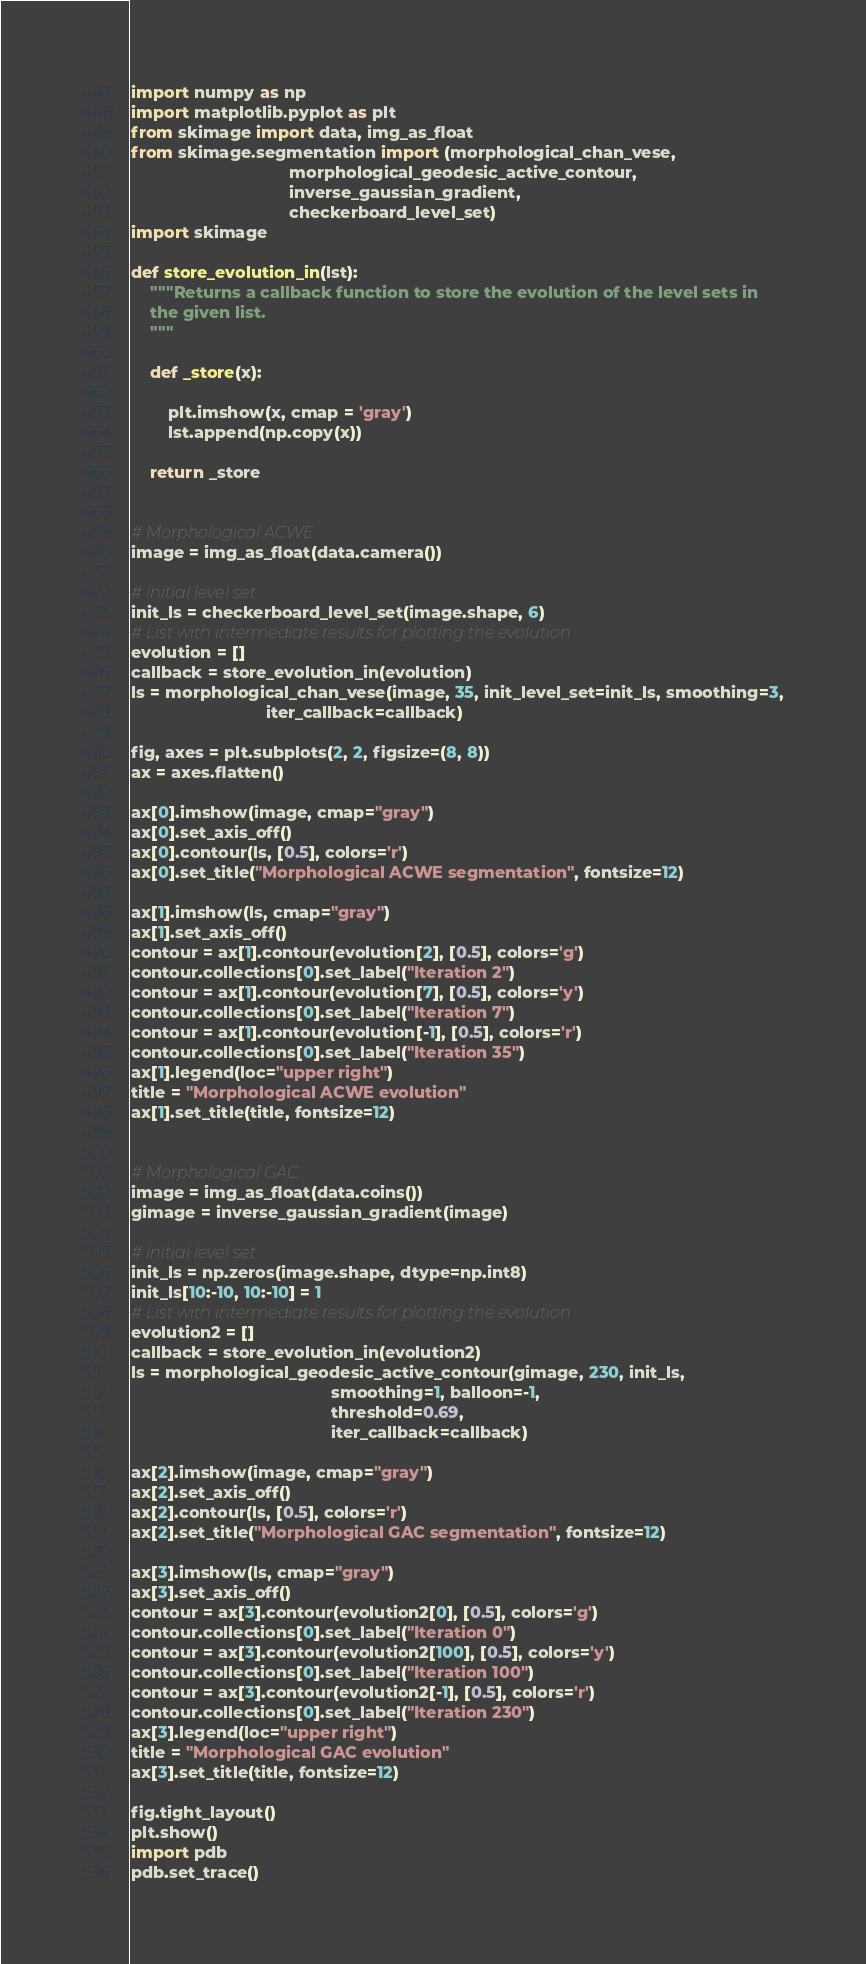<code> <loc_0><loc_0><loc_500><loc_500><_Python_>
import numpy as np
import matplotlib.pyplot as plt
from skimage import data, img_as_float
from skimage.segmentation import (morphological_chan_vese,
								  morphological_geodesic_active_contour,
								  inverse_gaussian_gradient,
								  checkerboard_level_set)
import skimage

def store_evolution_in(lst):
	"""Returns a callback function to store the evolution of the level sets in
	the given list.
	"""

	def _store(x):

		plt.imshow(x, cmap = 'gray')
		lst.append(np.copy(x))

	return _store


# Morphological ACWE
image = img_as_float(data.camera())

# Initial level set
init_ls = checkerboard_level_set(image.shape, 6)
# List with intermediate results for plotting the evolution
evolution = []
callback = store_evolution_in(evolution)
ls = morphological_chan_vese(image, 35, init_level_set=init_ls, smoothing=3,
							 iter_callback=callback)

fig, axes = plt.subplots(2, 2, figsize=(8, 8))
ax = axes.flatten()

ax[0].imshow(image, cmap="gray")
ax[0].set_axis_off()
ax[0].contour(ls, [0.5], colors='r')
ax[0].set_title("Morphological ACWE segmentation", fontsize=12)

ax[1].imshow(ls, cmap="gray")
ax[1].set_axis_off()
contour = ax[1].contour(evolution[2], [0.5], colors='g')
contour.collections[0].set_label("Iteration 2")
contour = ax[1].contour(evolution[7], [0.5], colors='y')
contour.collections[0].set_label("Iteration 7")
contour = ax[1].contour(evolution[-1], [0.5], colors='r')
contour.collections[0].set_label("Iteration 35")
ax[1].legend(loc="upper right")
title = "Morphological ACWE evolution"
ax[1].set_title(title, fontsize=12)


# Morphological GAC
image = img_as_float(data.coins())
gimage = inverse_gaussian_gradient(image)

# Initial level set
init_ls = np.zeros(image.shape, dtype=np.int8)
init_ls[10:-10, 10:-10] = 1
# List with intermediate results for plotting the evolution
evolution2 = []
callback = store_evolution_in(evolution2)
ls = morphological_geodesic_active_contour(gimage, 230, init_ls,
										   smoothing=1, balloon=-1,
										   threshold=0.69,
										   iter_callback=callback)

ax[2].imshow(image, cmap="gray")
ax[2].set_axis_off()
ax[2].contour(ls, [0.5], colors='r')
ax[2].set_title("Morphological GAC segmentation", fontsize=12)

ax[3].imshow(ls, cmap="gray")
ax[3].set_axis_off()
contour = ax[3].contour(evolution2[0], [0.5], colors='g')
contour.collections[0].set_label("Iteration 0")
contour = ax[3].contour(evolution2[100], [0.5], colors='y')
contour.collections[0].set_label("Iteration 100")
contour = ax[3].contour(evolution2[-1], [0.5], colors='r')
contour.collections[0].set_label("Iteration 230")
ax[3].legend(loc="upper right")
title = "Morphological GAC evolution"
ax[3].set_title(title, fontsize=12)

fig.tight_layout()
plt.show()
import pdb
pdb.set_trace()</code> 